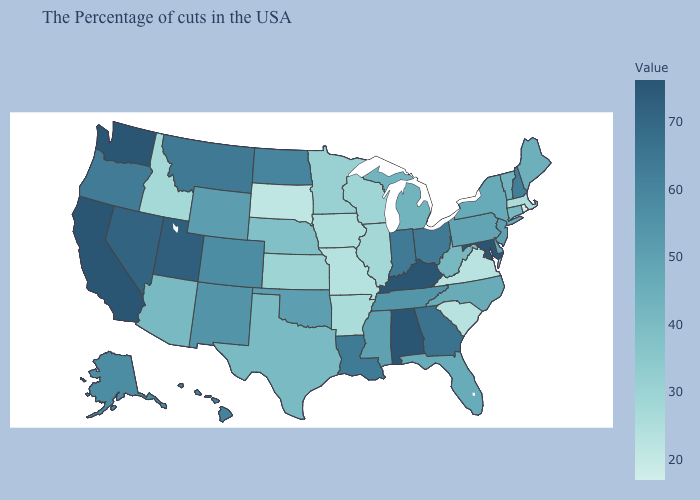Does Hawaii have the highest value in the West?
Write a very short answer. No. Does Hawaii have a lower value than Nevada?
Answer briefly. Yes. Does California have the highest value in the USA?
Short answer required. Yes. 